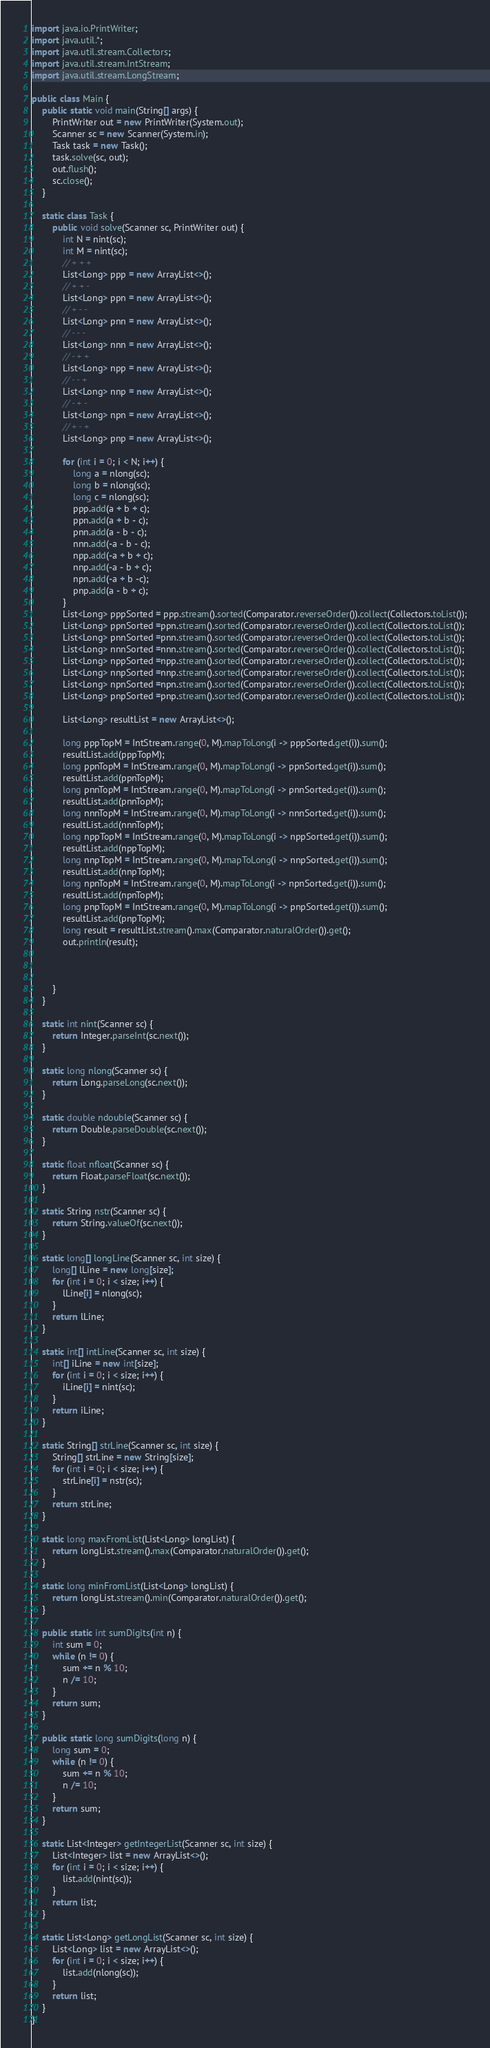<code> <loc_0><loc_0><loc_500><loc_500><_Java_>
import java.io.PrintWriter;
import java.util.*;
import java.util.stream.Collectors;
import java.util.stream.IntStream;
import java.util.stream.LongStream;

public class Main {
    public static void main(String[] args) {
        PrintWriter out = new PrintWriter(System.out);
        Scanner sc = new Scanner(System.in);
        Task task = new Task();
        task.solve(sc, out);
        out.flush();
        sc.close();
    }

    static class Task {
        public void solve(Scanner sc, PrintWriter out) {
            int N = nint(sc);
            int M = nint(sc);
            // + + +
            List<Long> ppp = new ArrayList<>();
            // + + -
            List<Long> ppn = new ArrayList<>();
            // + - -
            List<Long> pnn = new ArrayList<>();
            // - - -
            List<Long> nnn = new ArrayList<>();
            // - + +
            List<Long> npp = new ArrayList<>();
            // - - +
            List<Long> nnp = new ArrayList<>();
            // - + -
            List<Long> npn = new ArrayList<>();
            // + - +
            List<Long> pnp = new ArrayList<>();

            for (int i = 0; i < N; i++) {
                long a = nlong(sc);
                long b = nlong(sc);
                long c = nlong(sc);
                ppp.add(a + b + c);
                ppn.add(a + b - c);
                pnn.add(a - b - c);
                nnn.add(-a - b - c);
                npp.add(-a + b + c);
                nnp.add(-a - b + c);
                npn.add(-a + b -c);
                pnp.add(a - b + c);
            }
            List<Long> pppSorted = ppp.stream().sorted(Comparator.reverseOrder()).collect(Collectors.toList());
            List<Long> ppnSorted =ppn.stream().sorted(Comparator.reverseOrder()).collect(Collectors.toList());
            List<Long> pnnSorted =pnn.stream().sorted(Comparator.reverseOrder()).collect(Collectors.toList());
            List<Long> nnnSorted =nnn.stream().sorted(Comparator.reverseOrder()).collect(Collectors.toList());
            List<Long> nppSorted =npp.stream().sorted(Comparator.reverseOrder()).collect(Collectors.toList());
            List<Long> nnpSorted =nnp.stream().sorted(Comparator.reverseOrder()).collect(Collectors.toList());
            List<Long> npnSorted =npn.stream().sorted(Comparator.reverseOrder()).collect(Collectors.toList());
            List<Long> pnpSorted =pnp.stream().sorted(Comparator.reverseOrder()).collect(Collectors.toList());

            List<Long> resultList = new ArrayList<>();

            long pppTopM = IntStream.range(0, M).mapToLong(i -> pppSorted.get(i)).sum();
            resultList.add(pppTopM);
            long ppnTopM = IntStream.range(0, M).mapToLong(i -> ppnSorted.get(i)).sum();
            resultList.add(ppnTopM);
            long pnnTopM = IntStream.range(0, M).mapToLong(i -> pnnSorted.get(i)).sum();
            resultList.add(pnnTopM);
            long nnnTopM = IntStream.range(0, M).mapToLong(i -> nnnSorted.get(i)).sum();
            resultList.add(nnnTopM);
            long nppTopM = IntStream.range(0, M).mapToLong(i -> nppSorted.get(i)).sum();
            resultList.add(nppTopM);
            long nnpTopM = IntStream.range(0, M).mapToLong(i -> nnpSorted.get(i)).sum();
            resultList.add(nnpTopM);
            long npnTopM = IntStream.range(0, M).mapToLong(i -> npnSorted.get(i)).sum();
            resultList.add(npnTopM);
            long pnpTopM = IntStream.range(0, M).mapToLong(i -> pnpSorted.get(i)).sum();
            resultList.add(pnpTopM);
            long result = resultList.stream().max(Comparator.naturalOrder()).get();
            out.println(result);



        }
    }

    static int nint(Scanner sc) {
        return Integer.parseInt(sc.next());
    }

    static long nlong(Scanner sc) {
        return Long.parseLong(sc.next());
    }

    static double ndouble(Scanner sc) {
        return Double.parseDouble(sc.next());
    }

    static float nfloat(Scanner sc) {
        return Float.parseFloat(sc.next());
    }

    static String nstr(Scanner sc) {
        return String.valueOf(sc.next());
    }

    static long[] longLine(Scanner sc, int size) {
        long[] lLine = new long[size];
        for (int i = 0; i < size; i++) {
            lLine[i] = nlong(sc);
        }
        return lLine;
    }

    static int[] intLine(Scanner sc, int size) {
        int[] iLine = new int[size];
        for (int i = 0; i < size; i++) {
            iLine[i] = nint(sc);
        }
        return iLine;
    }

    static String[] strLine(Scanner sc, int size) {
        String[] strLine = new String[size];
        for (int i = 0; i < size; i++) {
            strLine[i] = nstr(sc);
        }
        return strLine;
    }

    static long maxFromList(List<Long> longList) {
        return longList.stream().max(Comparator.naturalOrder()).get();
    }

    static long minFromList(List<Long> longList) {
        return longList.stream().min(Comparator.naturalOrder()).get();
    }

    public static int sumDigits(int n) {
        int sum = 0;
        while (n != 0) {
            sum += n % 10;
            n /= 10;
        }
        return sum;
    }

    public static long sumDigits(long n) {
        long sum = 0;
        while (n != 0) {
            sum += n % 10;
            n /= 10;
        }
        return sum;
    }

    static List<Integer> getIntegerList(Scanner sc, int size) {
        List<Integer> list = new ArrayList<>();
        for (int i = 0; i < size; i++) {
            list.add(nint(sc));
        }
        return list;
    }

    static List<Long> getLongList(Scanner sc, int size) {
        List<Long> list = new ArrayList<>();
        for (int i = 0; i < size; i++) {
            list.add(nlong(sc));
        }
        return list;
    }
}
</code> 